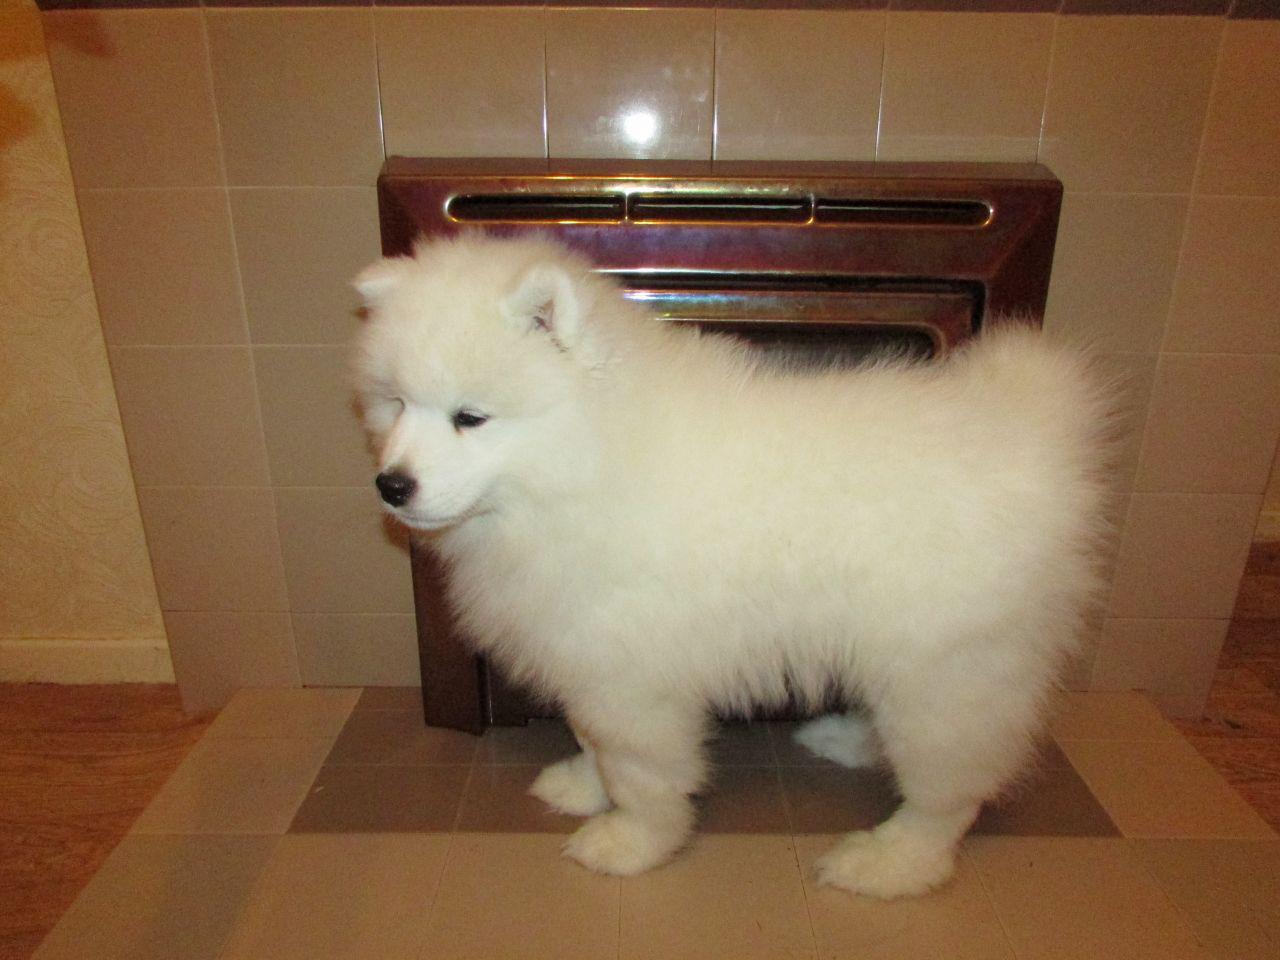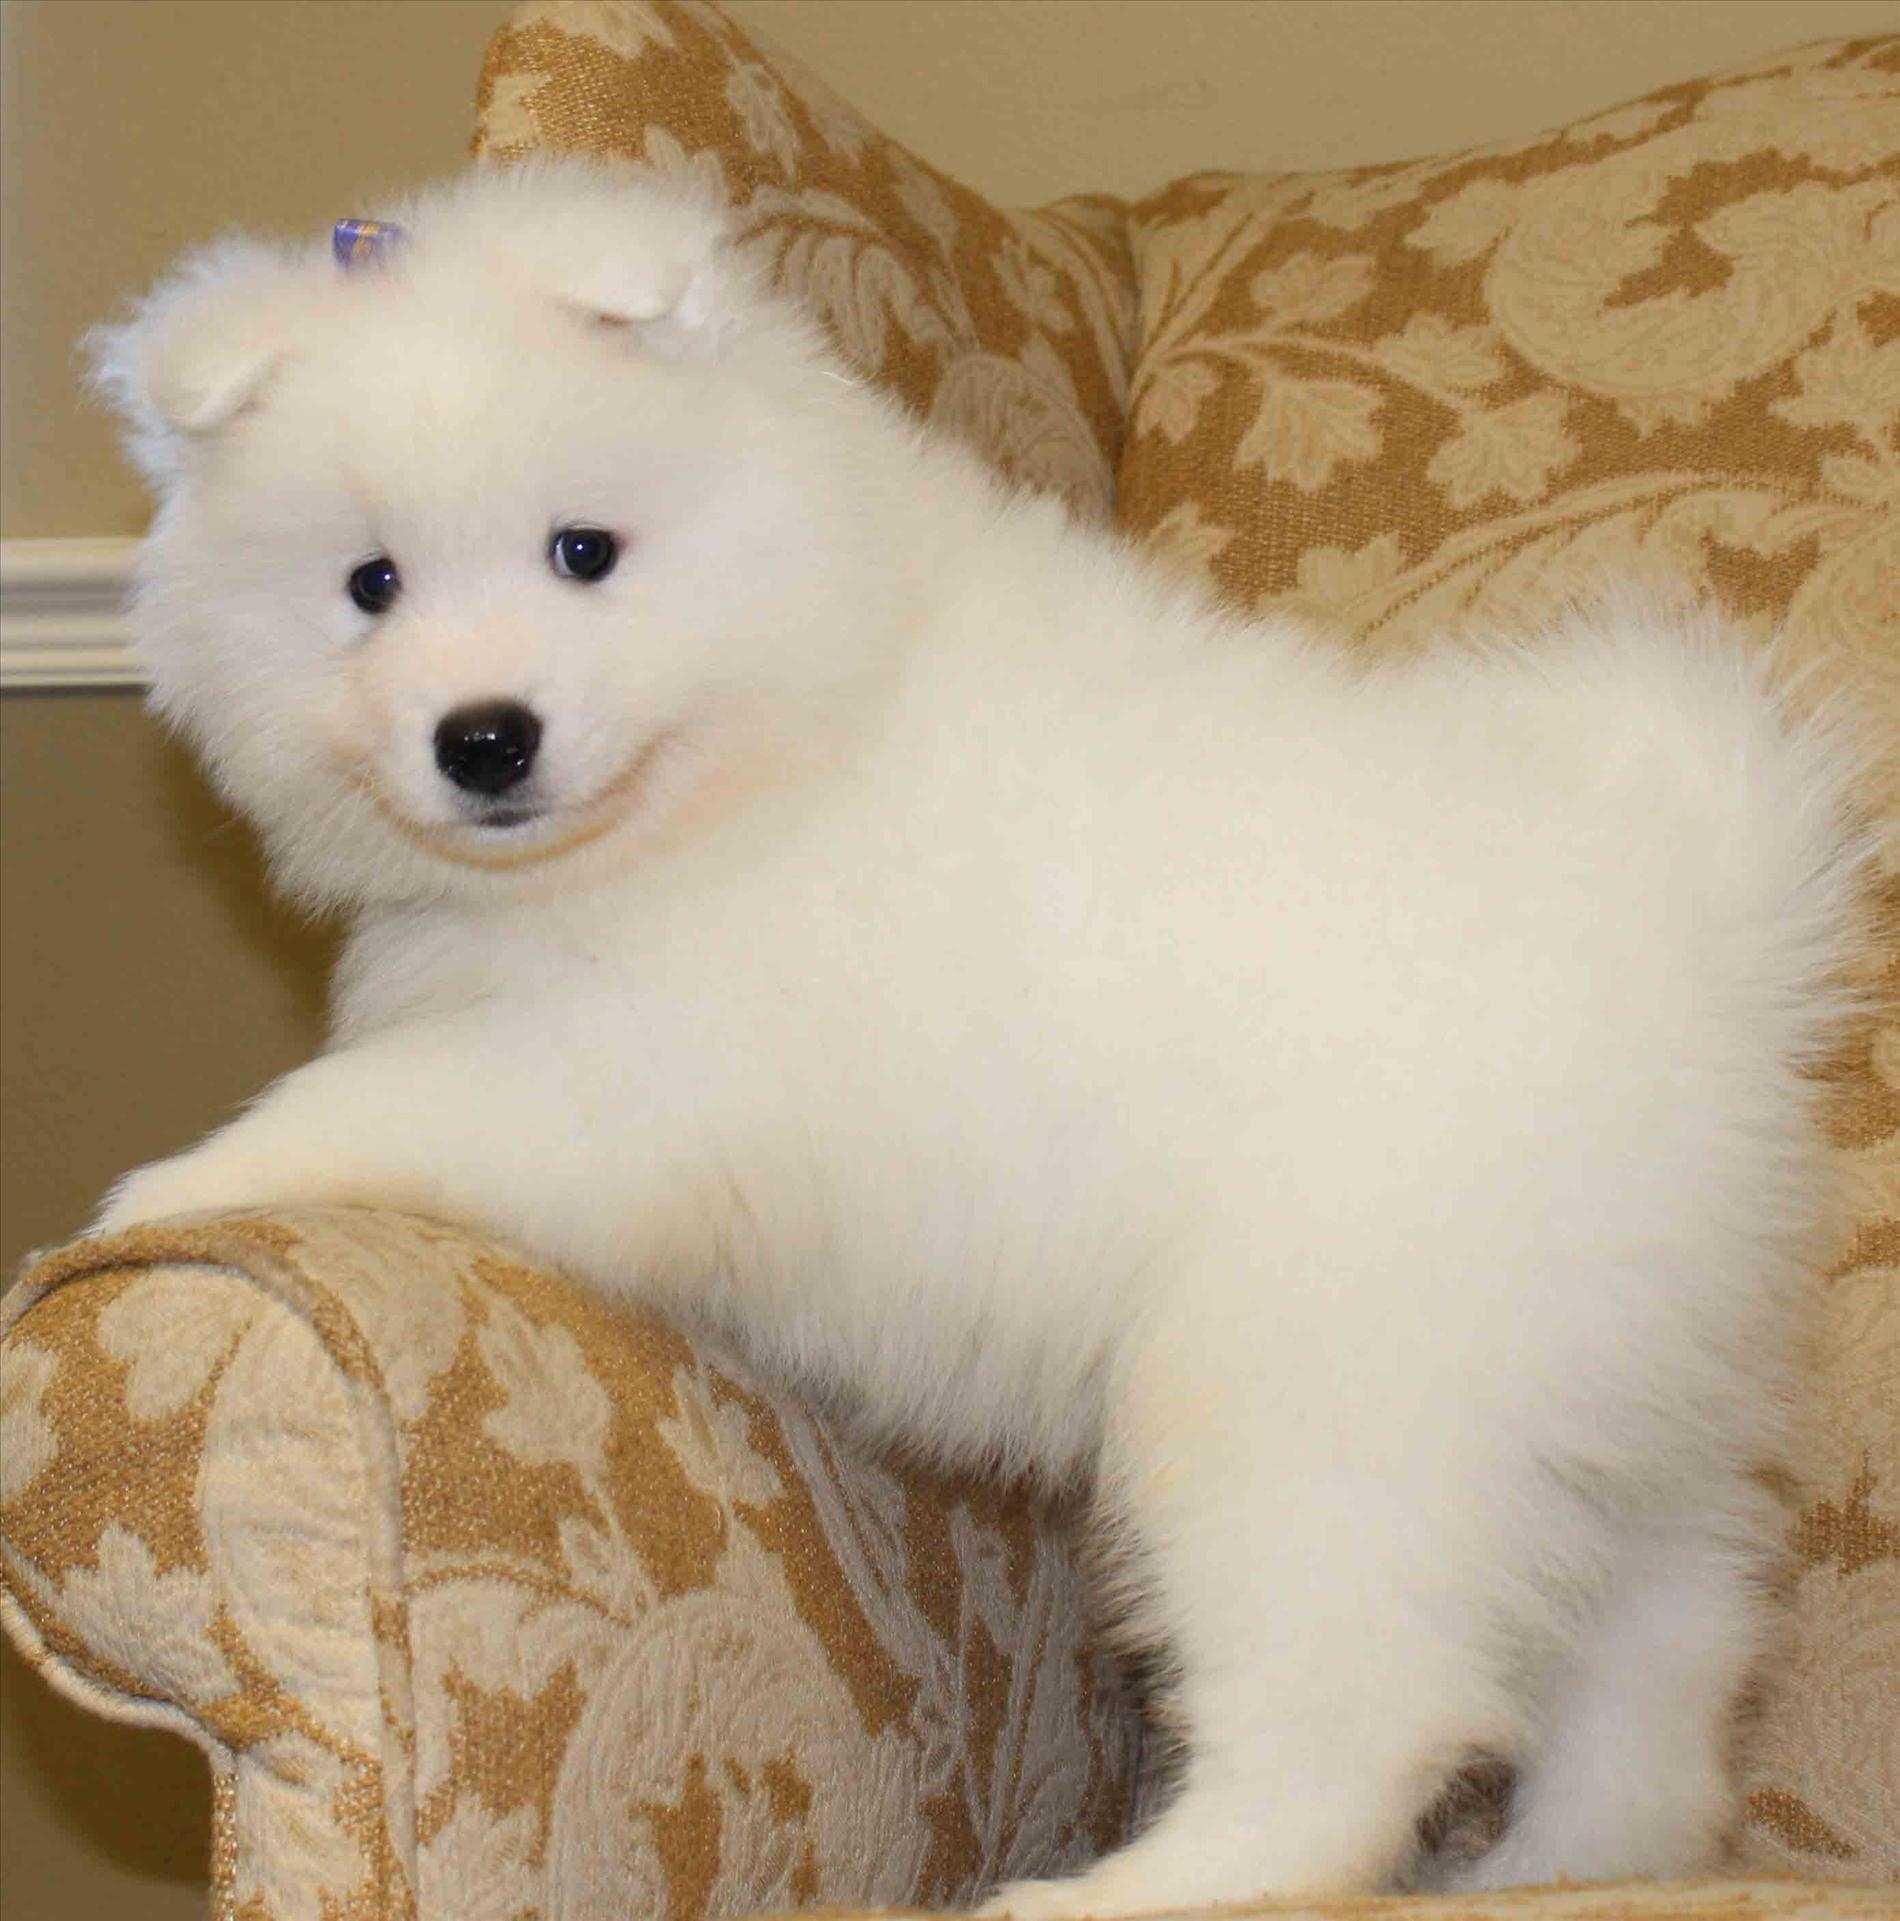The first image is the image on the left, the second image is the image on the right. Assess this claim about the two images: "An image includes more than one white dog in a prone position.". Correct or not? Answer yes or no. No. The first image is the image on the left, the second image is the image on the right. Assess this claim about the two images: "There are less than four dogs and none of them have their mouth open.". Correct or not? Answer yes or no. Yes. 